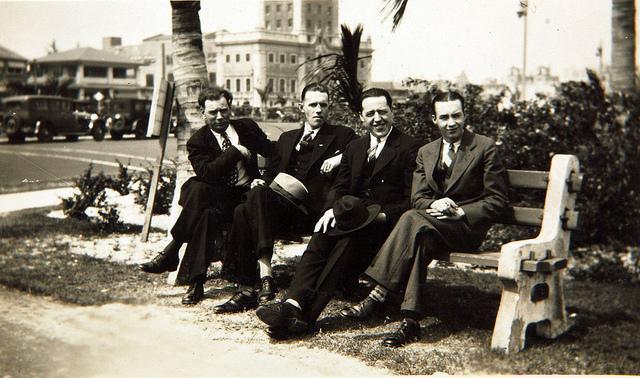How many people are visible?
Give a very brief answer. 4. 